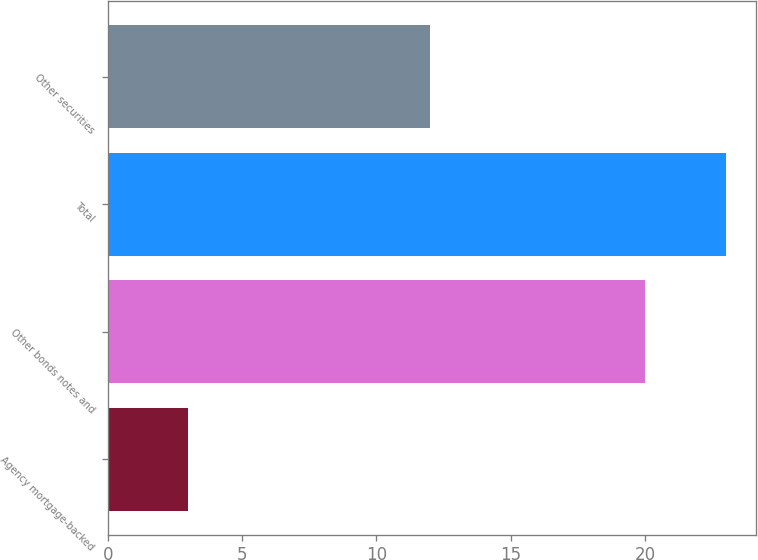<chart> <loc_0><loc_0><loc_500><loc_500><bar_chart><fcel>Agency mortgage-backed<fcel>Other bonds notes and<fcel>Total<fcel>Other securities<nl><fcel>3<fcel>20<fcel>23<fcel>12<nl></chart> 